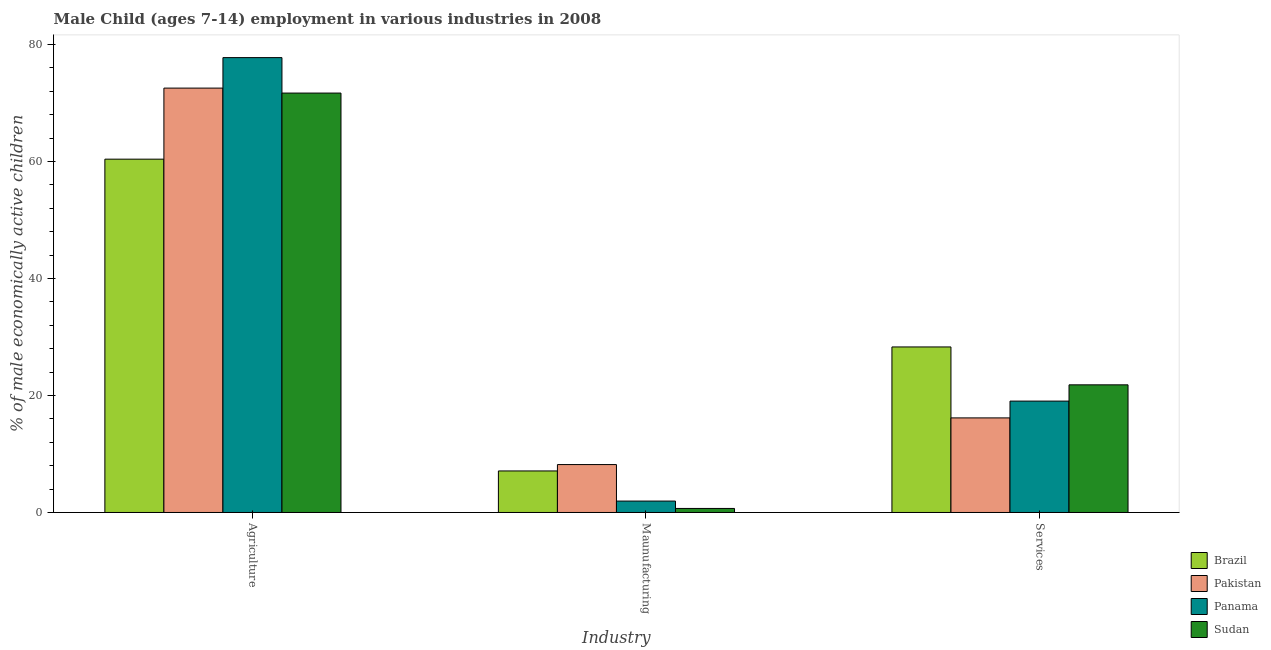How many groups of bars are there?
Provide a succinct answer. 3. Are the number of bars on each tick of the X-axis equal?
Your response must be concise. Yes. What is the label of the 2nd group of bars from the left?
Your answer should be very brief. Maunufacturing. Across all countries, what is the maximum percentage of economically active children in agriculture?
Give a very brief answer. 77.76. Across all countries, what is the minimum percentage of economically active children in manufacturing?
Offer a very short reply. 0.69. In which country was the percentage of economically active children in agriculture maximum?
Ensure brevity in your answer.  Panama. What is the total percentage of economically active children in agriculture in the graph?
Make the answer very short. 282.41. What is the difference between the percentage of economically active children in services in Panama and that in Sudan?
Make the answer very short. -2.78. What is the difference between the percentage of economically active children in manufacturing in Panama and the percentage of economically active children in services in Pakistan?
Your answer should be compact. -14.22. What is the average percentage of economically active children in agriculture per country?
Offer a terse response. 70.6. What is the difference between the percentage of economically active children in services and percentage of economically active children in agriculture in Pakistan?
Offer a terse response. -56.38. In how many countries, is the percentage of economically active children in services greater than 20 %?
Keep it short and to the point. 2. What is the ratio of the percentage of economically active children in services in Pakistan to that in Panama?
Provide a short and direct response. 0.85. Is the percentage of economically active children in services in Pakistan less than that in Brazil?
Keep it short and to the point. Yes. What is the difference between the highest and the second highest percentage of economically active children in services?
Make the answer very short. 6.48. What is the difference between the highest and the lowest percentage of economically active children in agriculture?
Ensure brevity in your answer.  17.36. In how many countries, is the percentage of economically active children in manufacturing greater than the average percentage of economically active children in manufacturing taken over all countries?
Offer a very short reply. 2. What does the 1st bar from the right in Services represents?
Your response must be concise. Sudan. Is it the case that in every country, the sum of the percentage of economically active children in agriculture and percentage of economically active children in manufacturing is greater than the percentage of economically active children in services?
Ensure brevity in your answer.  Yes. How many bars are there?
Keep it short and to the point. 12. How many countries are there in the graph?
Ensure brevity in your answer.  4. What is the difference between two consecutive major ticks on the Y-axis?
Your response must be concise. 20. Are the values on the major ticks of Y-axis written in scientific E-notation?
Provide a short and direct response. No. Does the graph contain grids?
Ensure brevity in your answer.  No. Where does the legend appear in the graph?
Provide a short and direct response. Bottom right. How many legend labels are there?
Ensure brevity in your answer.  4. How are the legend labels stacked?
Offer a terse response. Vertical. What is the title of the graph?
Your answer should be very brief. Male Child (ages 7-14) employment in various industries in 2008. What is the label or title of the X-axis?
Your response must be concise. Industry. What is the label or title of the Y-axis?
Keep it short and to the point. % of male economically active children. What is the % of male economically active children of Brazil in Agriculture?
Provide a short and direct response. 60.4. What is the % of male economically active children in Pakistan in Agriculture?
Give a very brief answer. 72.55. What is the % of male economically active children of Panama in Agriculture?
Your response must be concise. 77.76. What is the % of male economically active children of Sudan in Agriculture?
Ensure brevity in your answer.  71.7. What is the % of male economically active children in Brazil in Maunufacturing?
Offer a very short reply. 7.1. What is the % of male economically active children of Pakistan in Maunufacturing?
Provide a succinct answer. 8.19. What is the % of male economically active children of Panama in Maunufacturing?
Offer a terse response. 1.95. What is the % of male economically active children in Sudan in Maunufacturing?
Offer a very short reply. 0.69. What is the % of male economically active children of Brazil in Services?
Provide a short and direct response. 28.3. What is the % of male economically active children in Pakistan in Services?
Your response must be concise. 16.17. What is the % of male economically active children of Panama in Services?
Ensure brevity in your answer.  19.04. What is the % of male economically active children of Sudan in Services?
Offer a very short reply. 21.82. Across all Industry, what is the maximum % of male economically active children of Brazil?
Keep it short and to the point. 60.4. Across all Industry, what is the maximum % of male economically active children in Pakistan?
Offer a very short reply. 72.55. Across all Industry, what is the maximum % of male economically active children of Panama?
Ensure brevity in your answer.  77.76. Across all Industry, what is the maximum % of male economically active children in Sudan?
Offer a very short reply. 71.7. Across all Industry, what is the minimum % of male economically active children in Pakistan?
Offer a terse response. 8.19. Across all Industry, what is the minimum % of male economically active children in Panama?
Your response must be concise. 1.95. Across all Industry, what is the minimum % of male economically active children of Sudan?
Offer a very short reply. 0.69. What is the total % of male economically active children of Brazil in the graph?
Ensure brevity in your answer.  95.8. What is the total % of male economically active children in Pakistan in the graph?
Provide a succinct answer. 96.91. What is the total % of male economically active children of Panama in the graph?
Ensure brevity in your answer.  98.75. What is the total % of male economically active children of Sudan in the graph?
Your answer should be very brief. 94.21. What is the difference between the % of male economically active children of Brazil in Agriculture and that in Maunufacturing?
Provide a succinct answer. 53.3. What is the difference between the % of male economically active children in Pakistan in Agriculture and that in Maunufacturing?
Keep it short and to the point. 64.36. What is the difference between the % of male economically active children of Panama in Agriculture and that in Maunufacturing?
Keep it short and to the point. 75.81. What is the difference between the % of male economically active children of Sudan in Agriculture and that in Maunufacturing?
Give a very brief answer. 71.01. What is the difference between the % of male economically active children of Brazil in Agriculture and that in Services?
Keep it short and to the point. 32.1. What is the difference between the % of male economically active children in Pakistan in Agriculture and that in Services?
Ensure brevity in your answer.  56.38. What is the difference between the % of male economically active children of Panama in Agriculture and that in Services?
Provide a succinct answer. 58.72. What is the difference between the % of male economically active children in Sudan in Agriculture and that in Services?
Keep it short and to the point. 49.88. What is the difference between the % of male economically active children in Brazil in Maunufacturing and that in Services?
Your response must be concise. -21.2. What is the difference between the % of male economically active children in Pakistan in Maunufacturing and that in Services?
Provide a succinct answer. -7.98. What is the difference between the % of male economically active children in Panama in Maunufacturing and that in Services?
Keep it short and to the point. -17.09. What is the difference between the % of male economically active children of Sudan in Maunufacturing and that in Services?
Keep it short and to the point. -21.13. What is the difference between the % of male economically active children in Brazil in Agriculture and the % of male economically active children in Pakistan in Maunufacturing?
Offer a terse response. 52.21. What is the difference between the % of male economically active children of Brazil in Agriculture and the % of male economically active children of Panama in Maunufacturing?
Offer a terse response. 58.45. What is the difference between the % of male economically active children in Brazil in Agriculture and the % of male economically active children in Sudan in Maunufacturing?
Make the answer very short. 59.71. What is the difference between the % of male economically active children of Pakistan in Agriculture and the % of male economically active children of Panama in Maunufacturing?
Provide a short and direct response. 70.6. What is the difference between the % of male economically active children in Pakistan in Agriculture and the % of male economically active children in Sudan in Maunufacturing?
Provide a short and direct response. 71.86. What is the difference between the % of male economically active children of Panama in Agriculture and the % of male economically active children of Sudan in Maunufacturing?
Ensure brevity in your answer.  77.07. What is the difference between the % of male economically active children of Brazil in Agriculture and the % of male economically active children of Pakistan in Services?
Offer a very short reply. 44.23. What is the difference between the % of male economically active children in Brazil in Agriculture and the % of male economically active children in Panama in Services?
Provide a short and direct response. 41.36. What is the difference between the % of male economically active children in Brazil in Agriculture and the % of male economically active children in Sudan in Services?
Give a very brief answer. 38.58. What is the difference between the % of male economically active children of Pakistan in Agriculture and the % of male economically active children of Panama in Services?
Your answer should be compact. 53.51. What is the difference between the % of male economically active children of Pakistan in Agriculture and the % of male economically active children of Sudan in Services?
Ensure brevity in your answer.  50.73. What is the difference between the % of male economically active children in Panama in Agriculture and the % of male economically active children in Sudan in Services?
Make the answer very short. 55.94. What is the difference between the % of male economically active children of Brazil in Maunufacturing and the % of male economically active children of Pakistan in Services?
Your answer should be compact. -9.07. What is the difference between the % of male economically active children in Brazil in Maunufacturing and the % of male economically active children in Panama in Services?
Offer a very short reply. -11.94. What is the difference between the % of male economically active children in Brazil in Maunufacturing and the % of male economically active children in Sudan in Services?
Ensure brevity in your answer.  -14.72. What is the difference between the % of male economically active children in Pakistan in Maunufacturing and the % of male economically active children in Panama in Services?
Provide a succinct answer. -10.85. What is the difference between the % of male economically active children of Pakistan in Maunufacturing and the % of male economically active children of Sudan in Services?
Your response must be concise. -13.63. What is the difference between the % of male economically active children of Panama in Maunufacturing and the % of male economically active children of Sudan in Services?
Offer a very short reply. -19.87. What is the average % of male economically active children in Brazil per Industry?
Your answer should be compact. 31.93. What is the average % of male economically active children in Pakistan per Industry?
Keep it short and to the point. 32.3. What is the average % of male economically active children of Panama per Industry?
Give a very brief answer. 32.92. What is the average % of male economically active children of Sudan per Industry?
Offer a terse response. 31.4. What is the difference between the % of male economically active children in Brazil and % of male economically active children in Pakistan in Agriculture?
Your answer should be very brief. -12.15. What is the difference between the % of male economically active children in Brazil and % of male economically active children in Panama in Agriculture?
Keep it short and to the point. -17.36. What is the difference between the % of male economically active children of Brazil and % of male economically active children of Sudan in Agriculture?
Your response must be concise. -11.3. What is the difference between the % of male economically active children in Pakistan and % of male economically active children in Panama in Agriculture?
Offer a terse response. -5.21. What is the difference between the % of male economically active children of Pakistan and % of male economically active children of Sudan in Agriculture?
Make the answer very short. 0.85. What is the difference between the % of male economically active children of Panama and % of male economically active children of Sudan in Agriculture?
Provide a short and direct response. 6.06. What is the difference between the % of male economically active children of Brazil and % of male economically active children of Pakistan in Maunufacturing?
Keep it short and to the point. -1.09. What is the difference between the % of male economically active children of Brazil and % of male economically active children of Panama in Maunufacturing?
Make the answer very short. 5.15. What is the difference between the % of male economically active children of Brazil and % of male economically active children of Sudan in Maunufacturing?
Your answer should be very brief. 6.41. What is the difference between the % of male economically active children of Pakistan and % of male economically active children of Panama in Maunufacturing?
Your answer should be compact. 6.24. What is the difference between the % of male economically active children of Panama and % of male economically active children of Sudan in Maunufacturing?
Give a very brief answer. 1.26. What is the difference between the % of male economically active children in Brazil and % of male economically active children in Pakistan in Services?
Offer a very short reply. 12.13. What is the difference between the % of male economically active children in Brazil and % of male economically active children in Panama in Services?
Your response must be concise. 9.26. What is the difference between the % of male economically active children in Brazil and % of male economically active children in Sudan in Services?
Your answer should be compact. 6.48. What is the difference between the % of male economically active children in Pakistan and % of male economically active children in Panama in Services?
Provide a short and direct response. -2.87. What is the difference between the % of male economically active children of Pakistan and % of male economically active children of Sudan in Services?
Your response must be concise. -5.65. What is the difference between the % of male economically active children in Panama and % of male economically active children in Sudan in Services?
Keep it short and to the point. -2.78. What is the ratio of the % of male economically active children of Brazil in Agriculture to that in Maunufacturing?
Offer a terse response. 8.51. What is the ratio of the % of male economically active children of Pakistan in Agriculture to that in Maunufacturing?
Your answer should be compact. 8.86. What is the ratio of the % of male economically active children in Panama in Agriculture to that in Maunufacturing?
Make the answer very short. 39.88. What is the ratio of the % of male economically active children of Sudan in Agriculture to that in Maunufacturing?
Your answer should be compact. 103.91. What is the ratio of the % of male economically active children in Brazil in Agriculture to that in Services?
Make the answer very short. 2.13. What is the ratio of the % of male economically active children of Pakistan in Agriculture to that in Services?
Keep it short and to the point. 4.49. What is the ratio of the % of male economically active children in Panama in Agriculture to that in Services?
Ensure brevity in your answer.  4.08. What is the ratio of the % of male economically active children of Sudan in Agriculture to that in Services?
Provide a succinct answer. 3.29. What is the ratio of the % of male economically active children in Brazil in Maunufacturing to that in Services?
Provide a succinct answer. 0.25. What is the ratio of the % of male economically active children of Pakistan in Maunufacturing to that in Services?
Make the answer very short. 0.51. What is the ratio of the % of male economically active children in Panama in Maunufacturing to that in Services?
Your answer should be very brief. 0.1. What is the ratio of the % of male economically active children in Sudan in Maunufacturing to that in Services?
Your answer should be very brief. 0.03. What is the difference between the highest and the second highest % of male economically active children in Brazil?
Make the answer very short. 32.1. What is the difference between the highest and the second highest % of male economically active children in Pakistan?
Ensure brevity in your answer.  56.38. What is the difference between the highest and the second highest % of male economically active children of Panama?
Keep it short and to the point. 58.72. What is the difference between the highest and the second highest % of male economically active children of Sudan?
Your response must be concise. 49.88. What is the difference between the highest and the lowest % of male economically active children in Brazil?
Your answer should be very brief. 53.3. What is the difference between the highest and the lowest % of male economically active children in Pakistan?
Give a very brief answer. 64.36. What is the difference between the highest and the lowest % of male economically active children of Panama?
Your answer should be compact. 75.81. What is the difference between the highest and the lowest % of male economically active children of Sudan?
Keep it short and to the point. 71.01. 